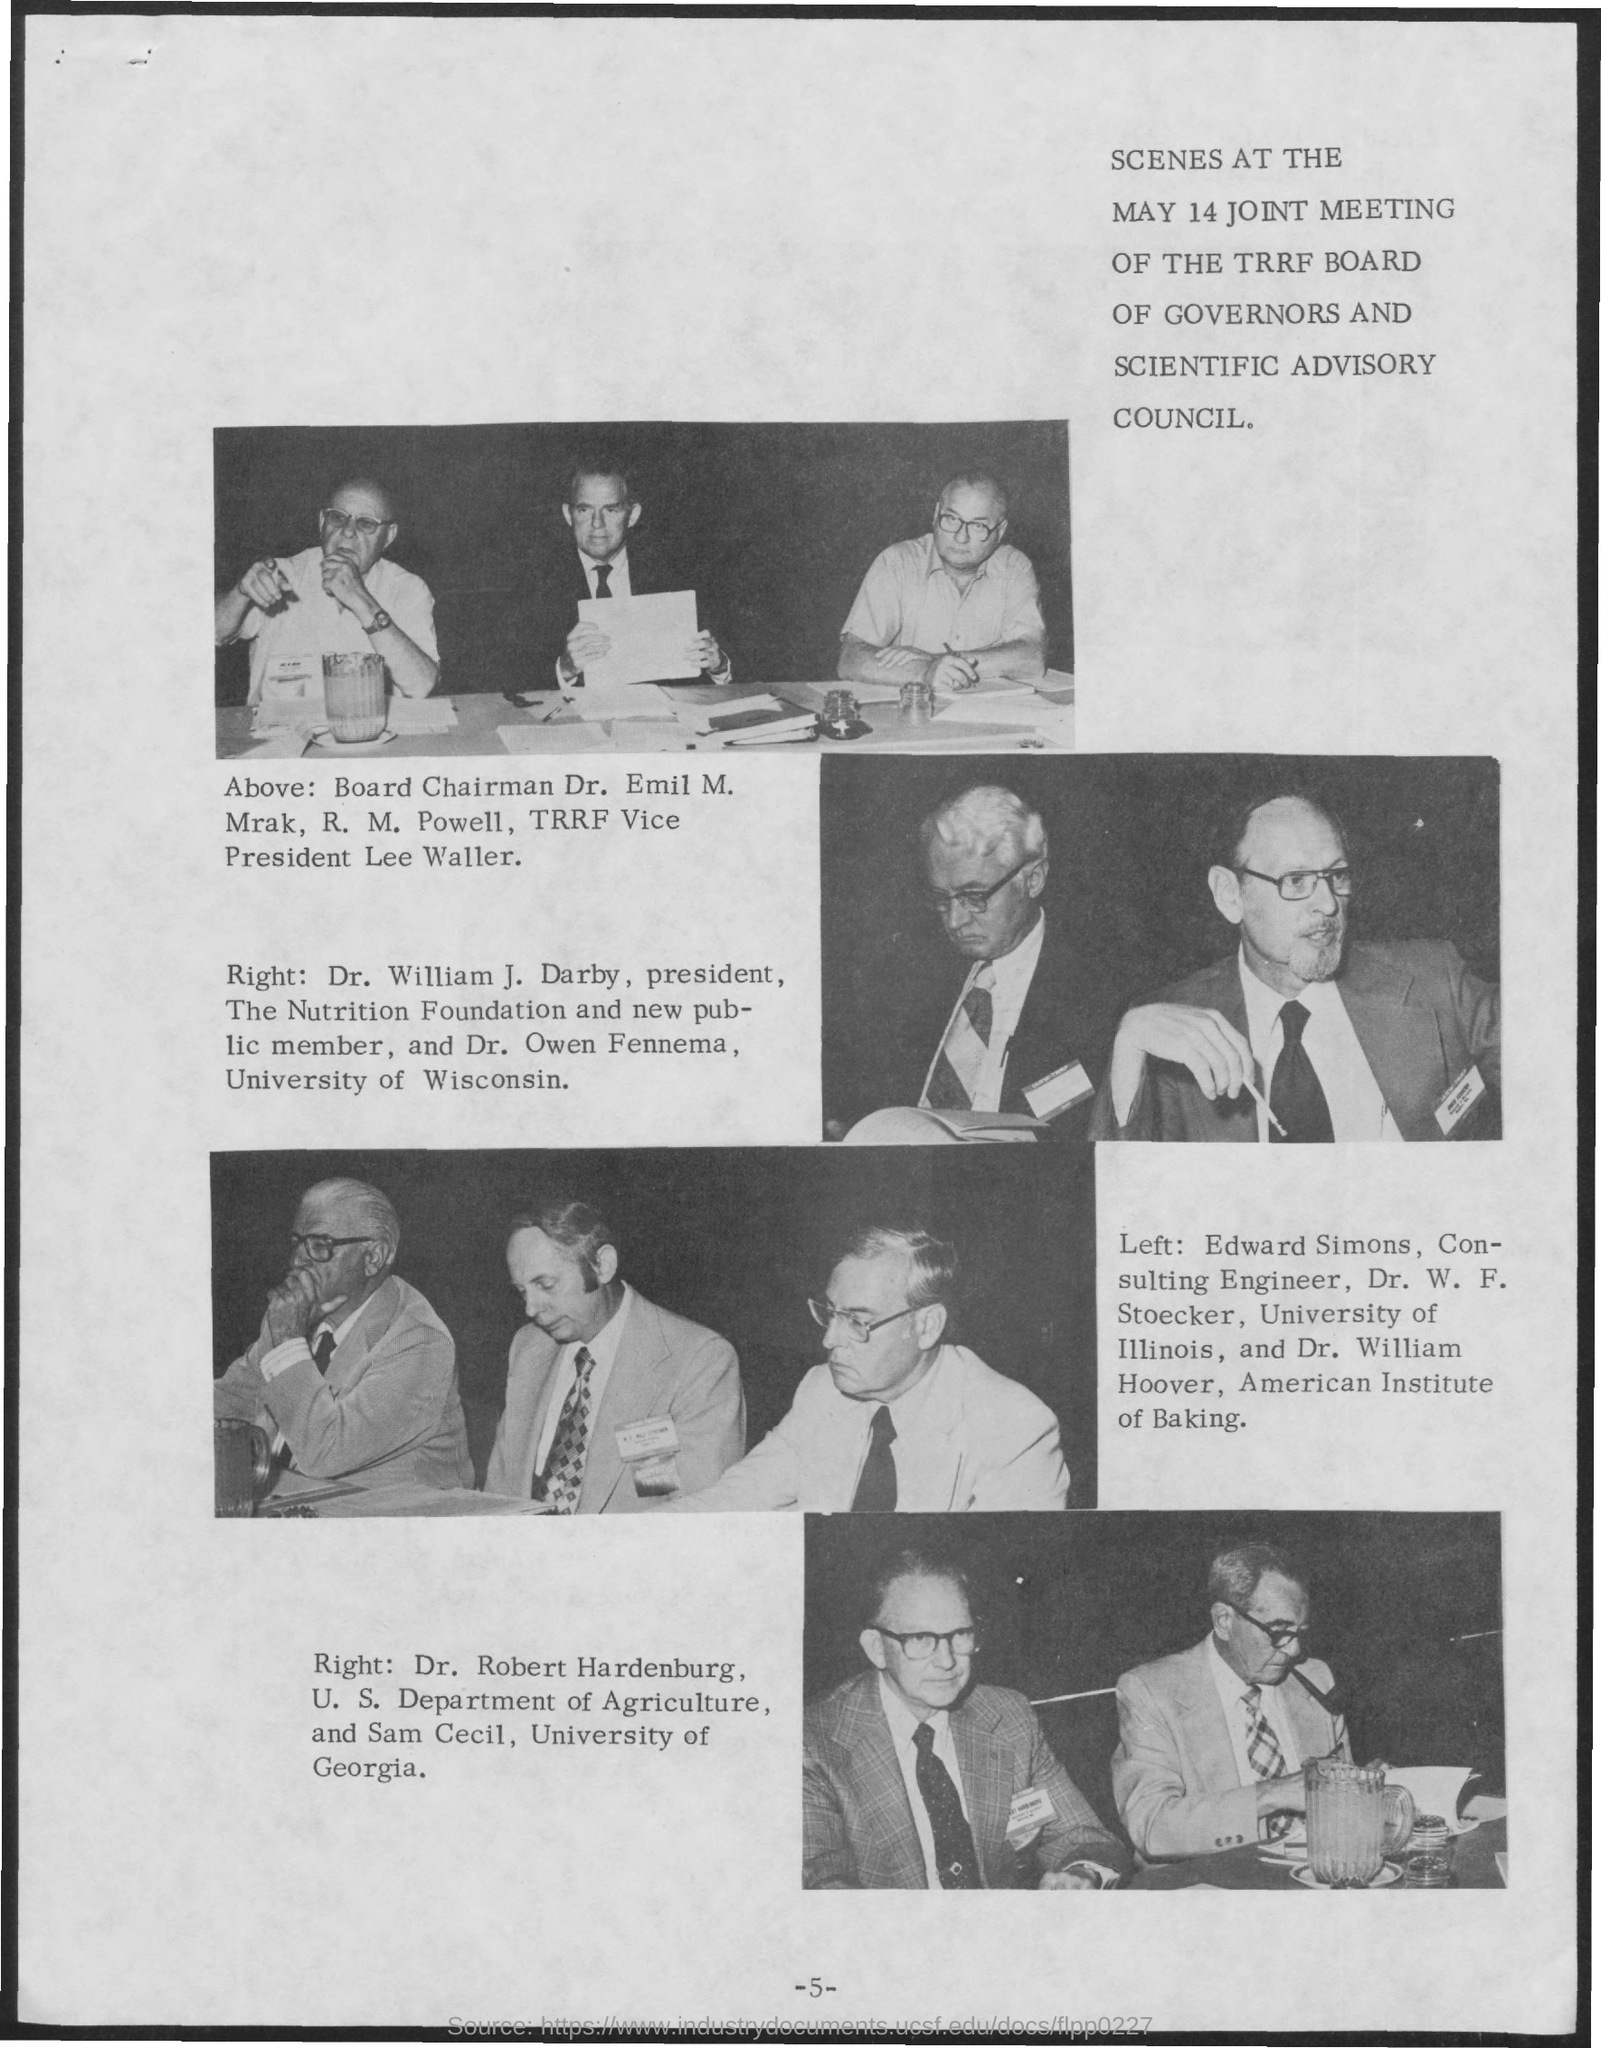Who is the Board Chairman?
Your response must be concise. Dr. Emil M. Mrak. Who all participated for the may 14 meeting?
Keep it short and to the point. JOINT MEETING OF THE TRRF BOARD OF GOVERNORS AND SCIENTIFIC ADVISORY COUNCIL. Who is Edward Simons?
Your response must be concise. Consulting Engineer. When was the joint meeting?
Keep it short and to the point. MAY 14. 